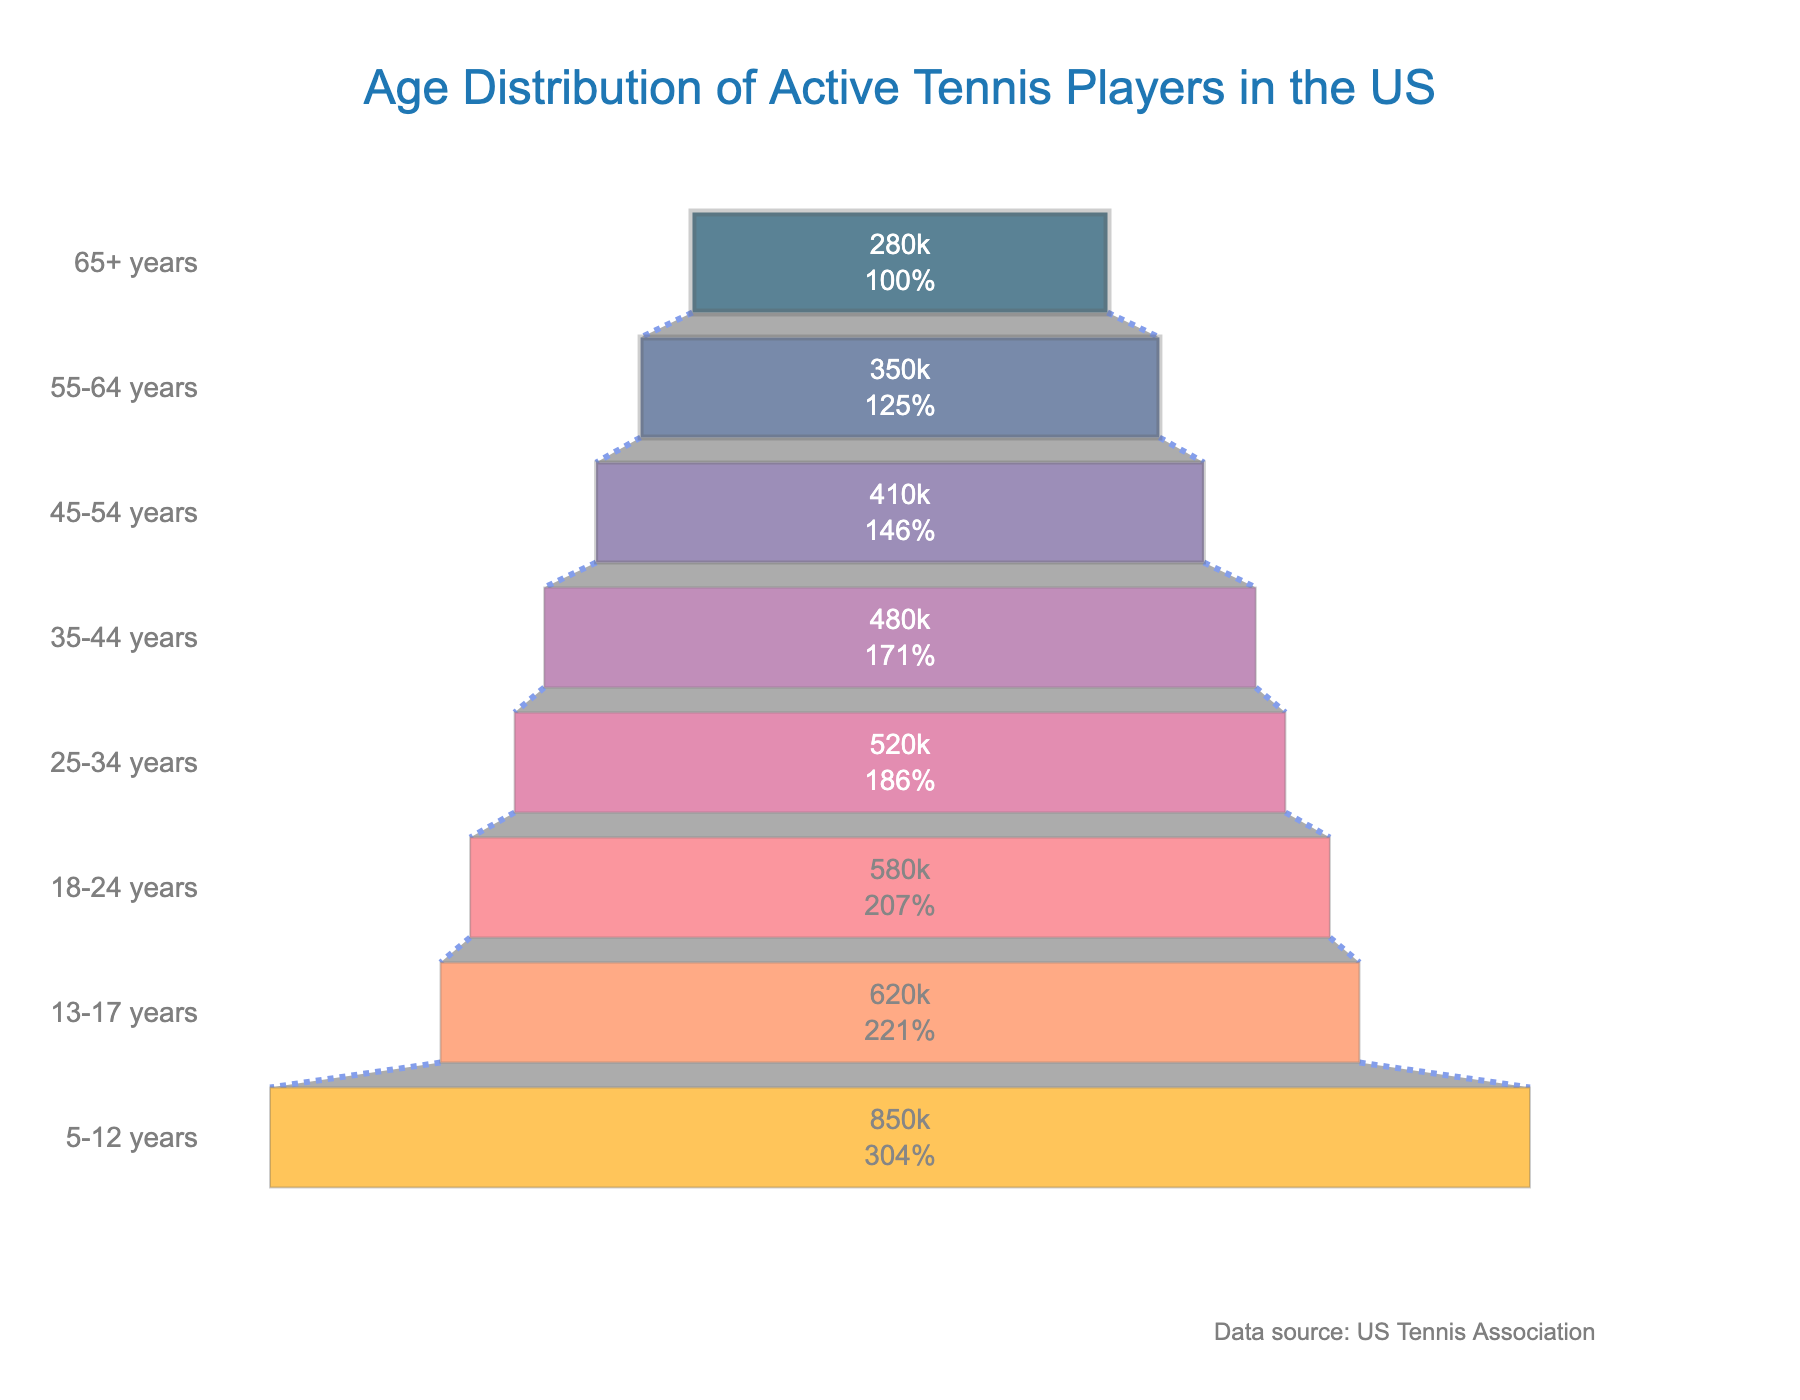What is the title of the funnel chart? The title is displayed at the top of the chart
Answer: Age Distribution of Active Tennis Players in the US Which age group has the highest number of active tennis players? Locate the widest section at the top of the funnel chart. This corresponds to the age group with the highest count.
Answer: 5-12 years How many active tennis players are in the 35-44 years age group? Find the section labeled "35-44 years" and see the number inside it.
Answer: 480,000 Which age group has the lowest number of active tennis players? Locate the narrowest section at the bottom of the funnel chart. This corresponds to the age group with the lowest count.
Answer: 65+ years How many more active tennis players are there in the 5-12 years group than in the 65+ years group? Subtract the number of active players in the 65+ years group from the number in the 5-12 years group. 850,000 - 280,000 = 570,000
Answer: 570,000 What is the total number of active tennis players in the 35-44 and 45-54 years age groups combined? Add the number of players in the 35-44 years age group to those in the 45-54 years age group. 480,000 + 410,000 = 890,000
Answer: 890,000 How many age groups are included in the funnel chart? Count the distinct sections in the funnel chart, each representing an age group.
Answer: 8 Which age group has a higher number of active players: 18-24 years or 45-54 years? Compare the numbers next to the sections labeled "18-24 years" and "45-54 years." 580,000 vs. 410,000
Answer: 18-24 years What is the percentage of active tennis players aged 55-64 years compared to the total number of players? Calculate the percentage by dividing the number of players aged 55-64 by the total number of players and multiplying by 100. (350,000 / 4,090,000) * 100 ≈ 8.56%
Answer: 8.56% Which age group saw the largest drop in the number of active tennis players when moving to the next older age group? Identify the sections with the largest difference between subsequent age groups. 5-12 years to 13-17 years shows the largest drop: 850,000 - 620,000 = 230,000
Answer: 5-12 years to 13-17 years 